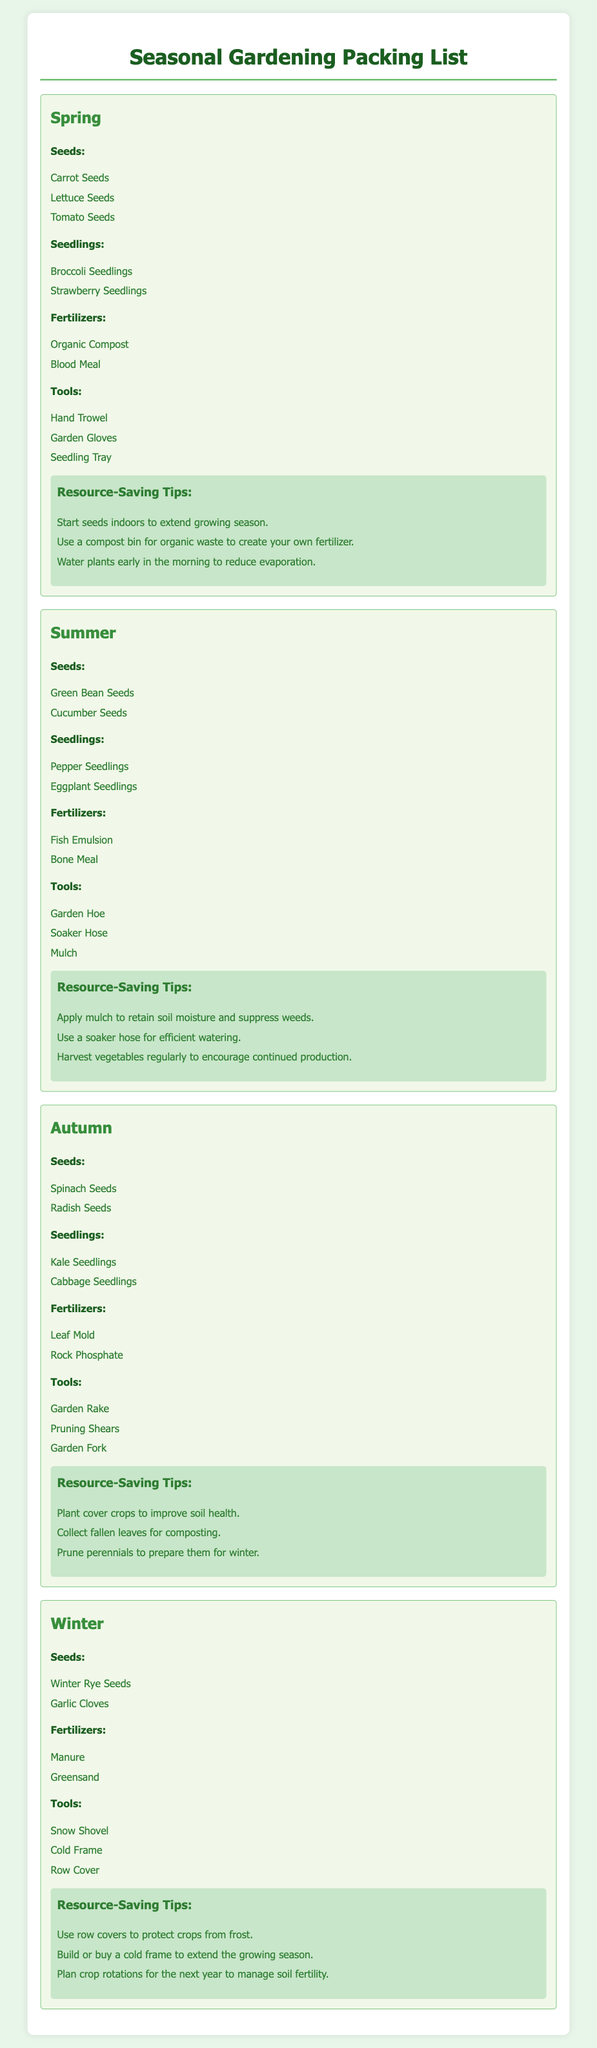what seeds are recommended for spring? The document lists carrot, lettuce, and tomato seeds as recommended for spring planting.
Answer: Carrot, Lettuce, Tomato how many types of seedlings are mentioned for summer? The document specifies two types of seedlings for summer, which are listed under the summer section.
Answer: 2 what is one recommended fertilizer for autumn? The document identifies leaf mold and rock phosphate as the fertilizers for autumn.
Answer: Leaf Mold which tool is listed for winter gardening? The document includes snow shovel, cold frame, and row cover as tools for winter gardening.
Answer: Snow Shovel what is a resource-saving tip for summer? The document suggests applying mulch to retain soil moisture and suppress weeds as a tip for summer.
Answer: Apply mulch which season has broccoli seedlings? The document states that broccoli seedlings are specifically mentioned in the spring section.
Answer: Spring how many categories of items are provided for each season? The document outlines four categories for each season, which include seeds, seedlings, fertilizers, and tools.
Answer: 4 what tool is suggested for autumn maintenance? The document lists garden rake, pruning shears, and garden fork as suggested tools for autumn maintenance.
Answer: Garden Rake what seeds are mentioned for winter planting? The document indicates winter rye seeds and garlic cloves as the seeds for winter.
Answer: Winter Rye, Garlic Cloves 